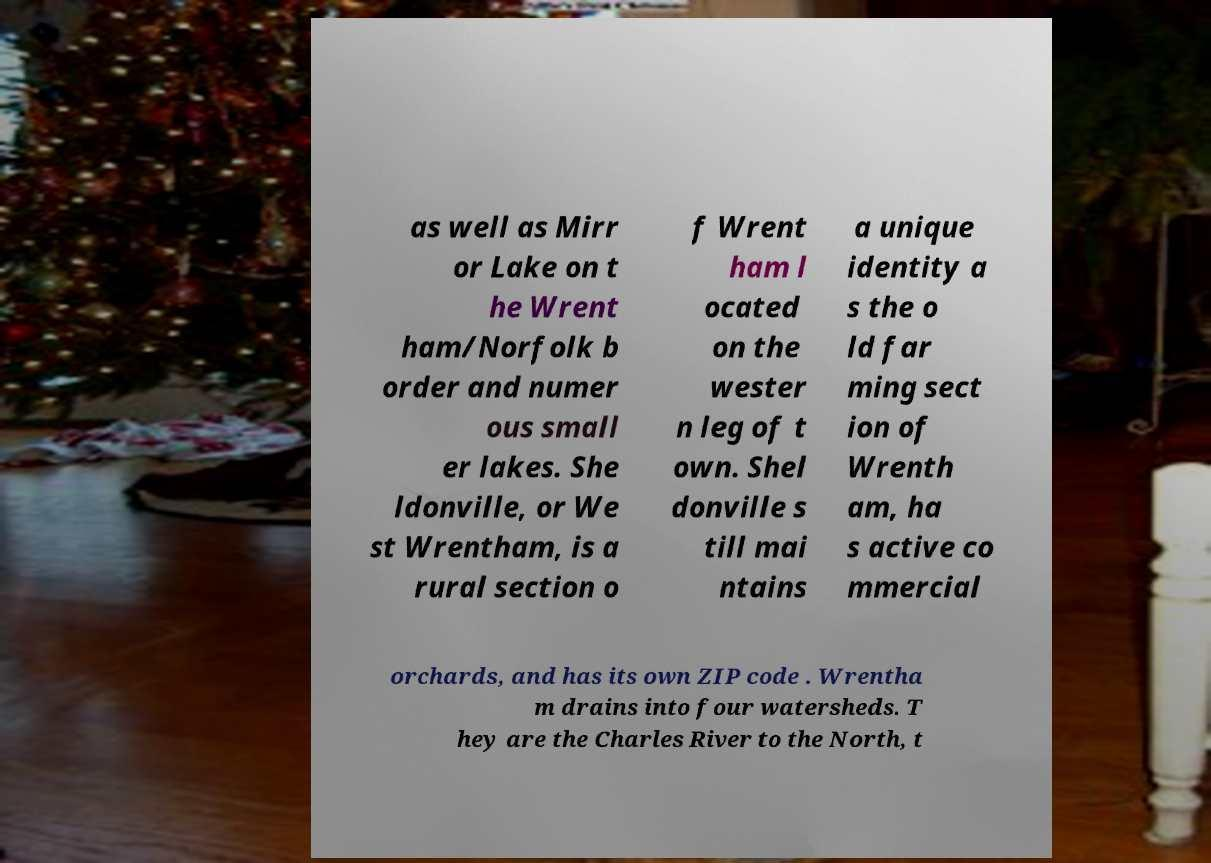Please read and relay the text visible in this image. What does it say? as well as Mirr or Lake on t he Wrent ham/Norfolk b order and numer ous small er lakes. She ldonville, or We st Wrentham, is a rural section o f Wrent ham l ocated on the wester n leg of t own. Shel donville s till mai ntains a unique identity a s the o ld far ming sect ion of Wrenth am, ha s active co mmercial orchards, and has its own ZIP code . Wrentha m drains into four watersheds. T hey are the Charles River to the North, t 